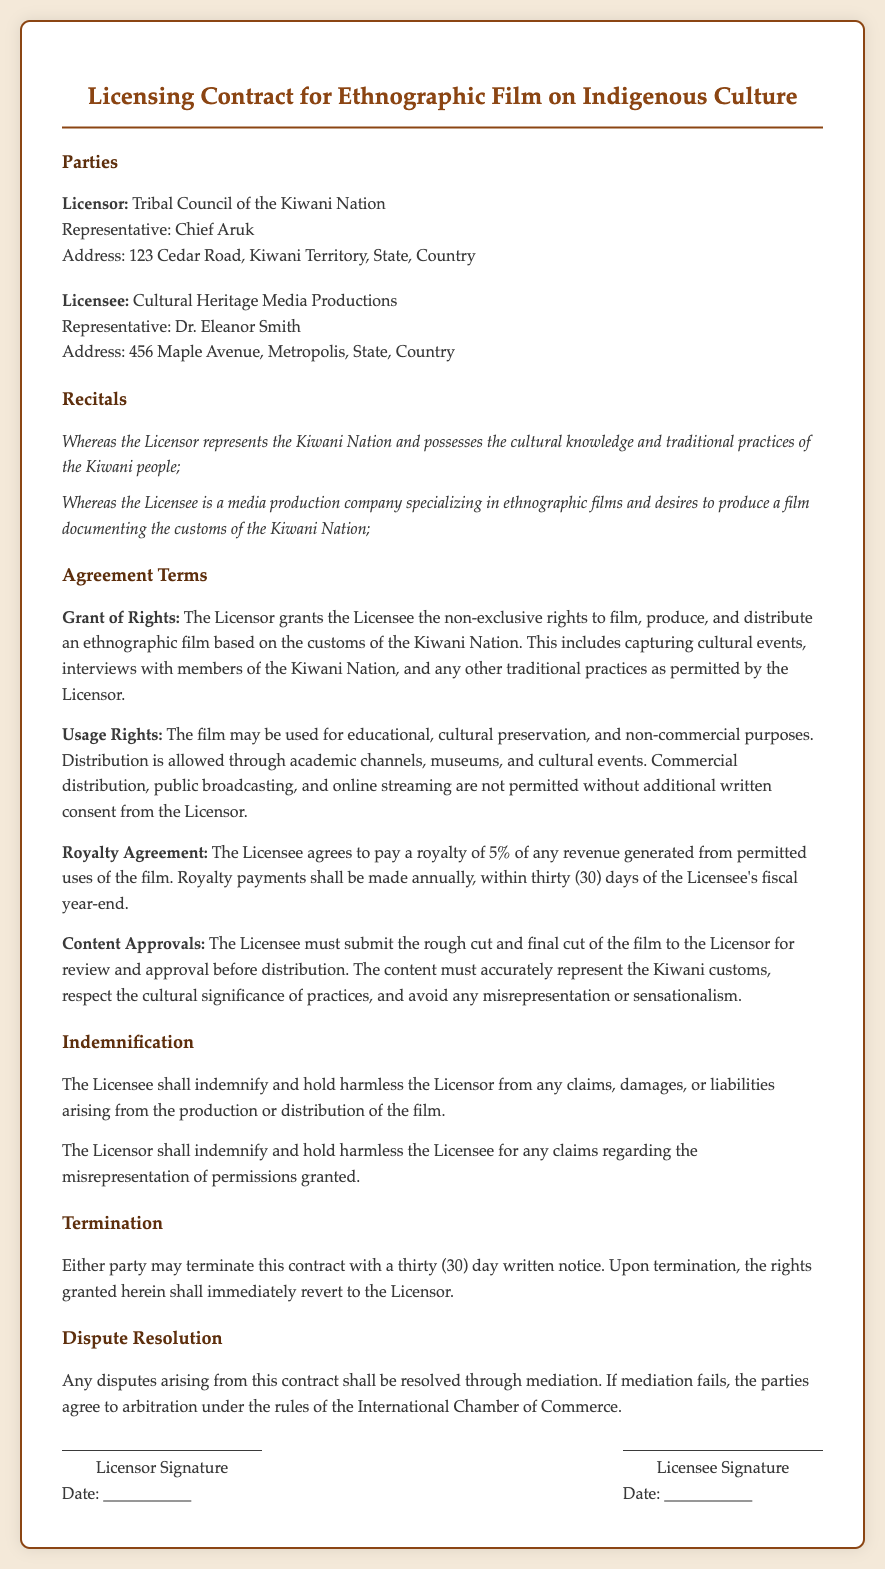What is the name of the Licensor? The Licensor is identified in the document as the Tribal Council of the Kiwani Nation.
Answer: Tribal Council of the Kiwani Nation Who is the representative of the Licensee? The representative of the Licensee is explicitly mentioned in the document.
Answer: Dr. Eleanor Smith What percentage is the royalty agreement set at? The document specifies the percentage of the royalty agreement within the relevant section.
Answer: 5% How long does the Licensee have to pay royalties? The payment period for royalty agreements is clearly defined in the contract.
Answer: thirty (30) days What must the Licensee submit for approval? The document states clearly what the Licensee is required to submit to the Licensor for approval before distribution.
Answer: rough cut and final cut What type of resolution process is mentioned for disputes? The document outlines the process to be followed in case of disputes.
Answer: mediation What is required for the Licensor to terminate the contract? The condition that allows the Licensor or Licensee to terminate the contract is specified in the document.
Answer: thirty (30) day written notice What address is listed for the Licensor? The address provided for the Licensor can be found in the parties section of the contract.
Answer: 123 Cedar Road, Kiwani Territory, State, Country What is the purpose of the film according to the usage rights? The document discusses the intended purpose of the film as outlined in the usage rights section.
Answer: educational, cultural preservation, and non-commercial purposes 